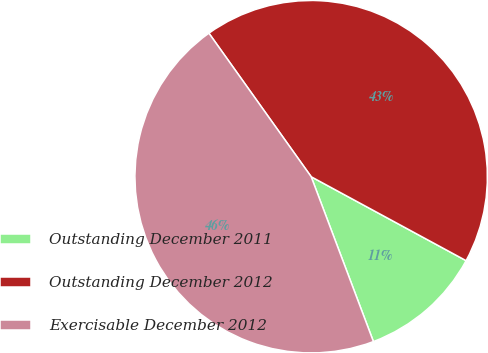Convert chart. <chart><loc_0><loc_0><loc_500><loc_500><pie_chart><fcel>Outstanding December 2011<fcel>Outstanding December 2012<fcel>Exercisable December 2012<nl><fcel>11.35%<fcel>42.75%<fcel>45.89%<nl></chart> 